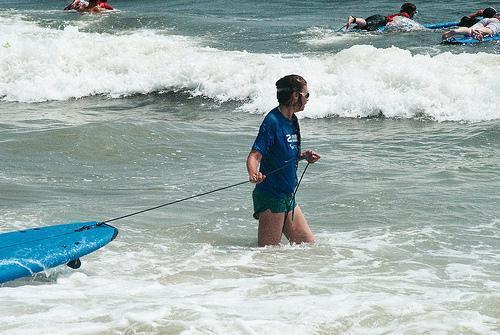How many strings are attached to board?
Give a very brief answer. 1. 